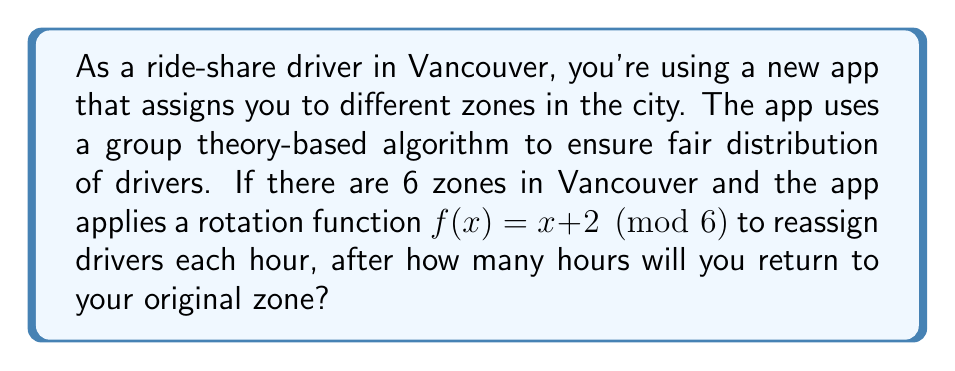Teach me how to tackle this problem. To solve this problem, we need to understand the concept of order in group theory:

1) First, let's consider the group of rotations modulo 6, which is isomorphic to $\mathbb{Z}_6$ (the integers modulo 6).

2) The function $f(x) = x + 2 \pmod{6}$ is a group action on this set.

3) We need to find the smallest positive integer $n$ such that applying $f$ $n$ times returns us to the starting point. In group theory terms, we're looking for the order of the element 2 in $\mathbb{Z}_6$.

4) Let's apply $f$ repeatedly:
   $f(x) = x + 2 \pmod{6}$
   $f(f(x)) = (x + 2) + 2 = x + 4 \pmod{6}$
   $f(f(f(x))) = (x + 4) + 2 = x + 6 \equiv x \pmod{6}$

5) We see that after applying $f$ three times, we return to our starting point.

6) This means that the order of 2 in $\mathbb{Z}_6$ is 3.

7) In terms of the ride-sharing app, this means you'll return to your original zone after 3 hours.
Answer: 3 hours 